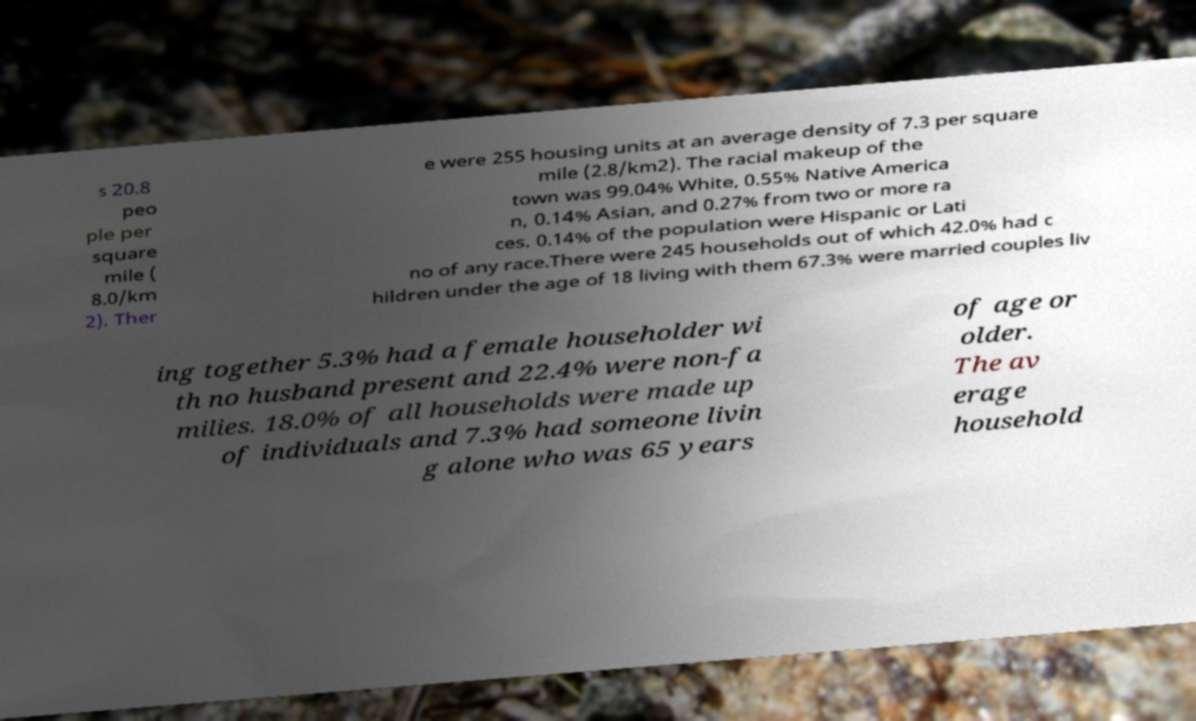Please identify and transcribe the text found in this image. s 20.8 peo ple per square mile ( 8.0/km 2). Ther e were 255 housing units at an average density of 7.3 per square mile (2.8/km2). The racial makeup of the town was 99.04% White, 0.55% Native America n, 0.14% Asian, and 0.27% from two or more ra ces. 0.14% of the population were Hispanic or Lati no of any race.There were 245 households out of which 42.0% had c hildren under the age of 18 living with them 67.3% were married couples liv ing together 5.3% had a female householder wi th no husband present and 22.4% were non-fa milies. 18.0% of all households were made up of individuals and 7.3% had someone livin g alone who was 65 years of age or older. The av erage household 